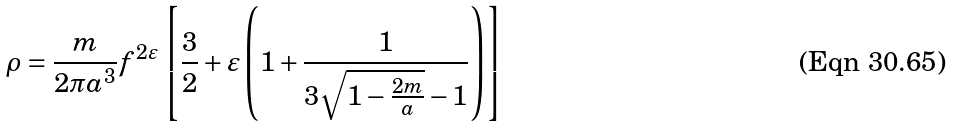<formula> <loc_0><loc_0><loc_500><loc_500>\rho = \frac { m } { 2 \pi a ^ { 3 } } f ^ { 2 \varepsilon } \left [ \frac { 3 } { 2 } + \varepsilon \left ( 1 + \frac { 1 } { 3 \sqrt { 1 - \frac { 2 m } { a } } - 1 } \right ) \right ]</formula> 